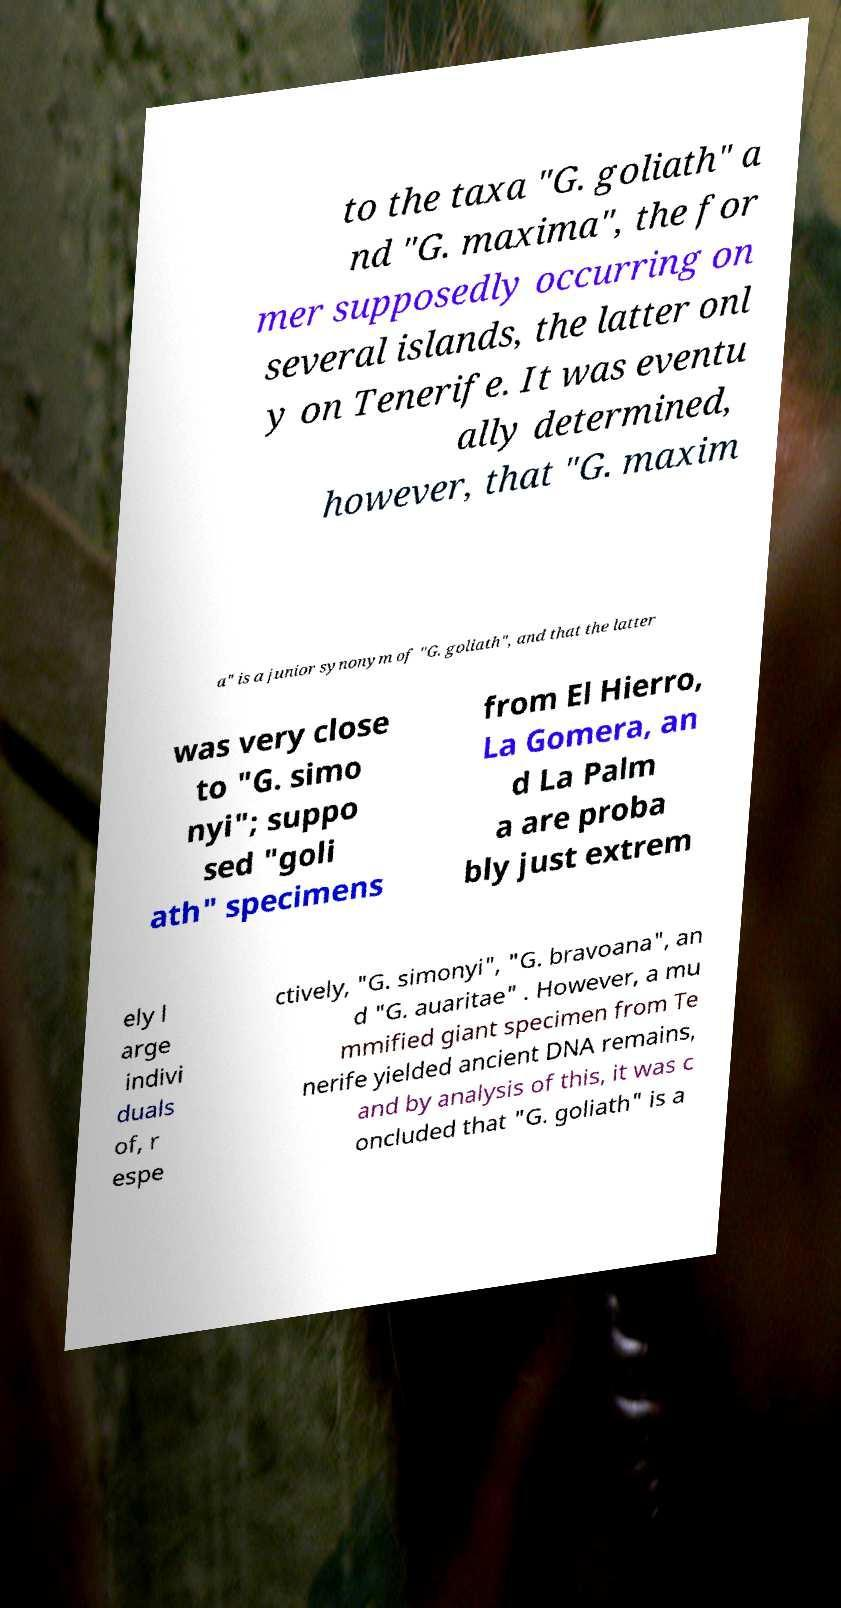Please identify and transcribe the text found in this image. to the taxa "G. goliath" a nd "G. maxima", the for mer supposedly occurring on several islands, the latter onl y on Tenerife. It was eventu ally determined, however, that "G. maxim a" is a junior synonym of "G. goliath", and that the latter was very close to "G. simo nyi"; suppo sed "goli ath" specimens from El Hierro, La Gomera, an d La Palm a are proba bly just extrem ely l arge indivi duals of, r espe ctively, "G. simonyi", "G. bravoana", an d "G. auaritae" . However, a mu mmified giant specimen from Te nerife yielded ancient DNA remains, and by analysis of this, it was c oncluded that "G. goliath" is a 